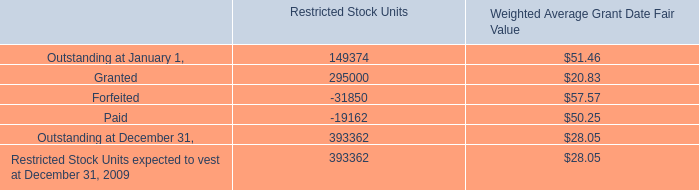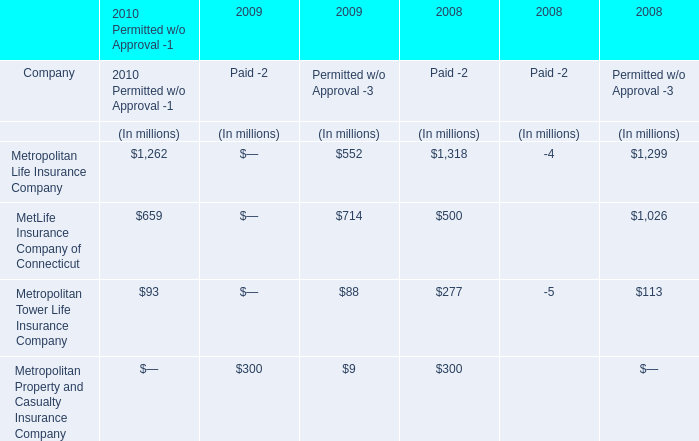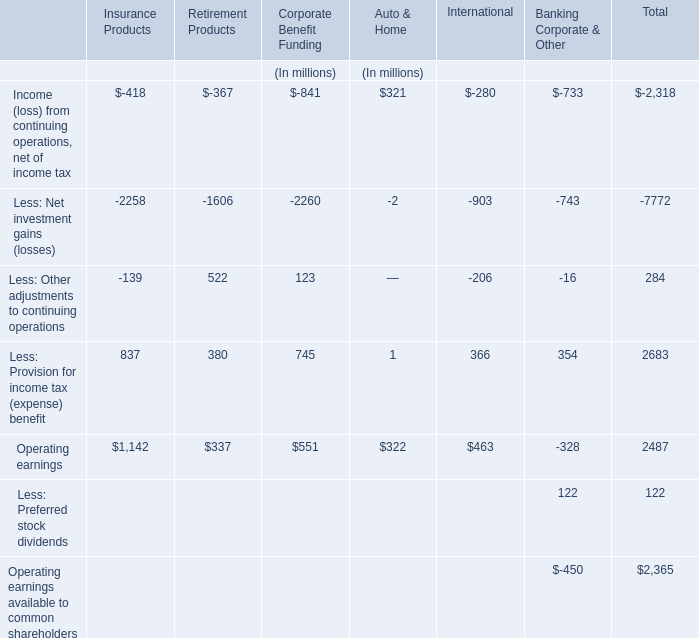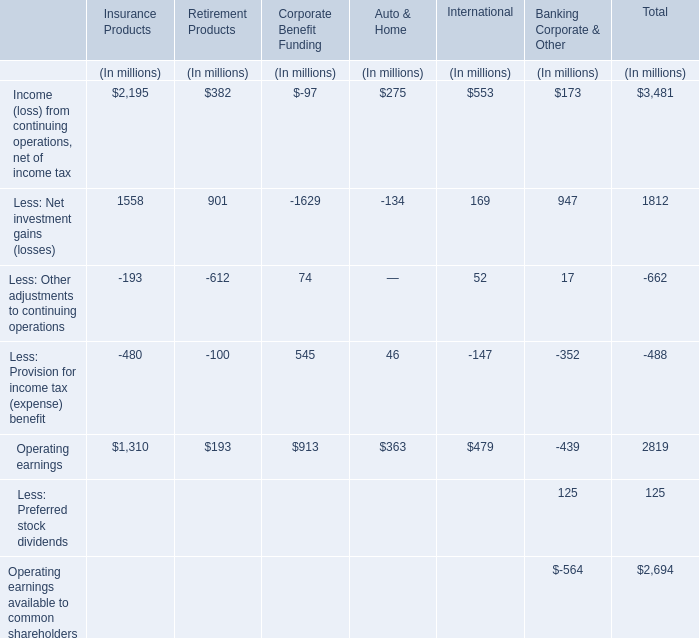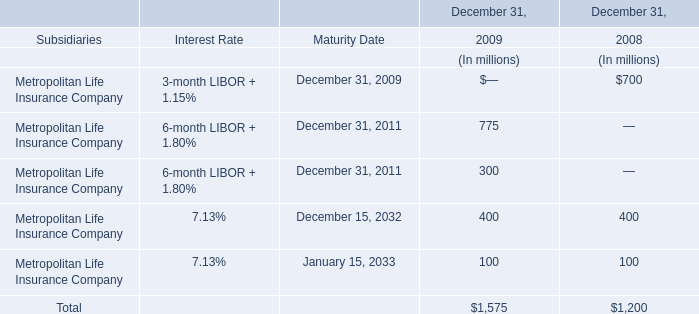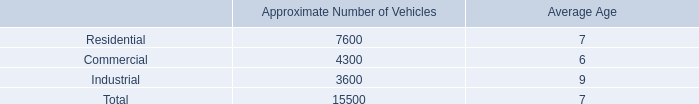what is the approximate number of vehicle in the fleet that are operating on compressed natural gas ( cng ) approximately 12% ( 12 % ) 
Computations: (15500 * 12%)
Answer: 1860.0. 